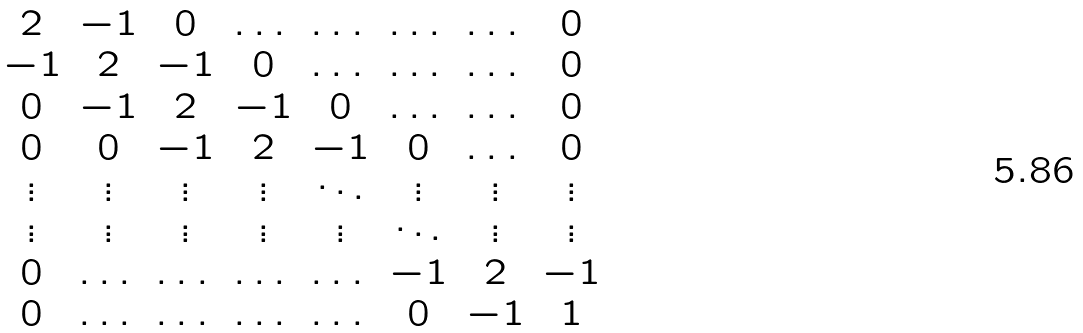<formula> <loc_0><loc_0><loc_500><loc_500>\begin{matrix} 2 & - 1 & 0 & \dots & \dots & \dots & \dots & 0 \\ - 1 & 2 & - 1 & 0 & \dots & \dots & \dots & 0 \\ 0 & - 1 & 2 & - 1 & 0 & \dots & \dots & 0 \\ 0 & 0 & - 1 & 2 & - 1 & 0 & \dots & 0 \\ \vdots & \vdots & \vdots & \vdots & \ddots & \vdots & \vdots & \vdots \\ \vdots & \vdots & \vdots & \vdots & \vdots & \ddots & \vdots & \vdots \\ 0 & \dots & \dots & \dots & \dots & - 1 & 2 & - 1 \\ 0 & \dots & \dots & \dots & \dots & 0 & - 1 & 1 \end{matrix}</formula> 